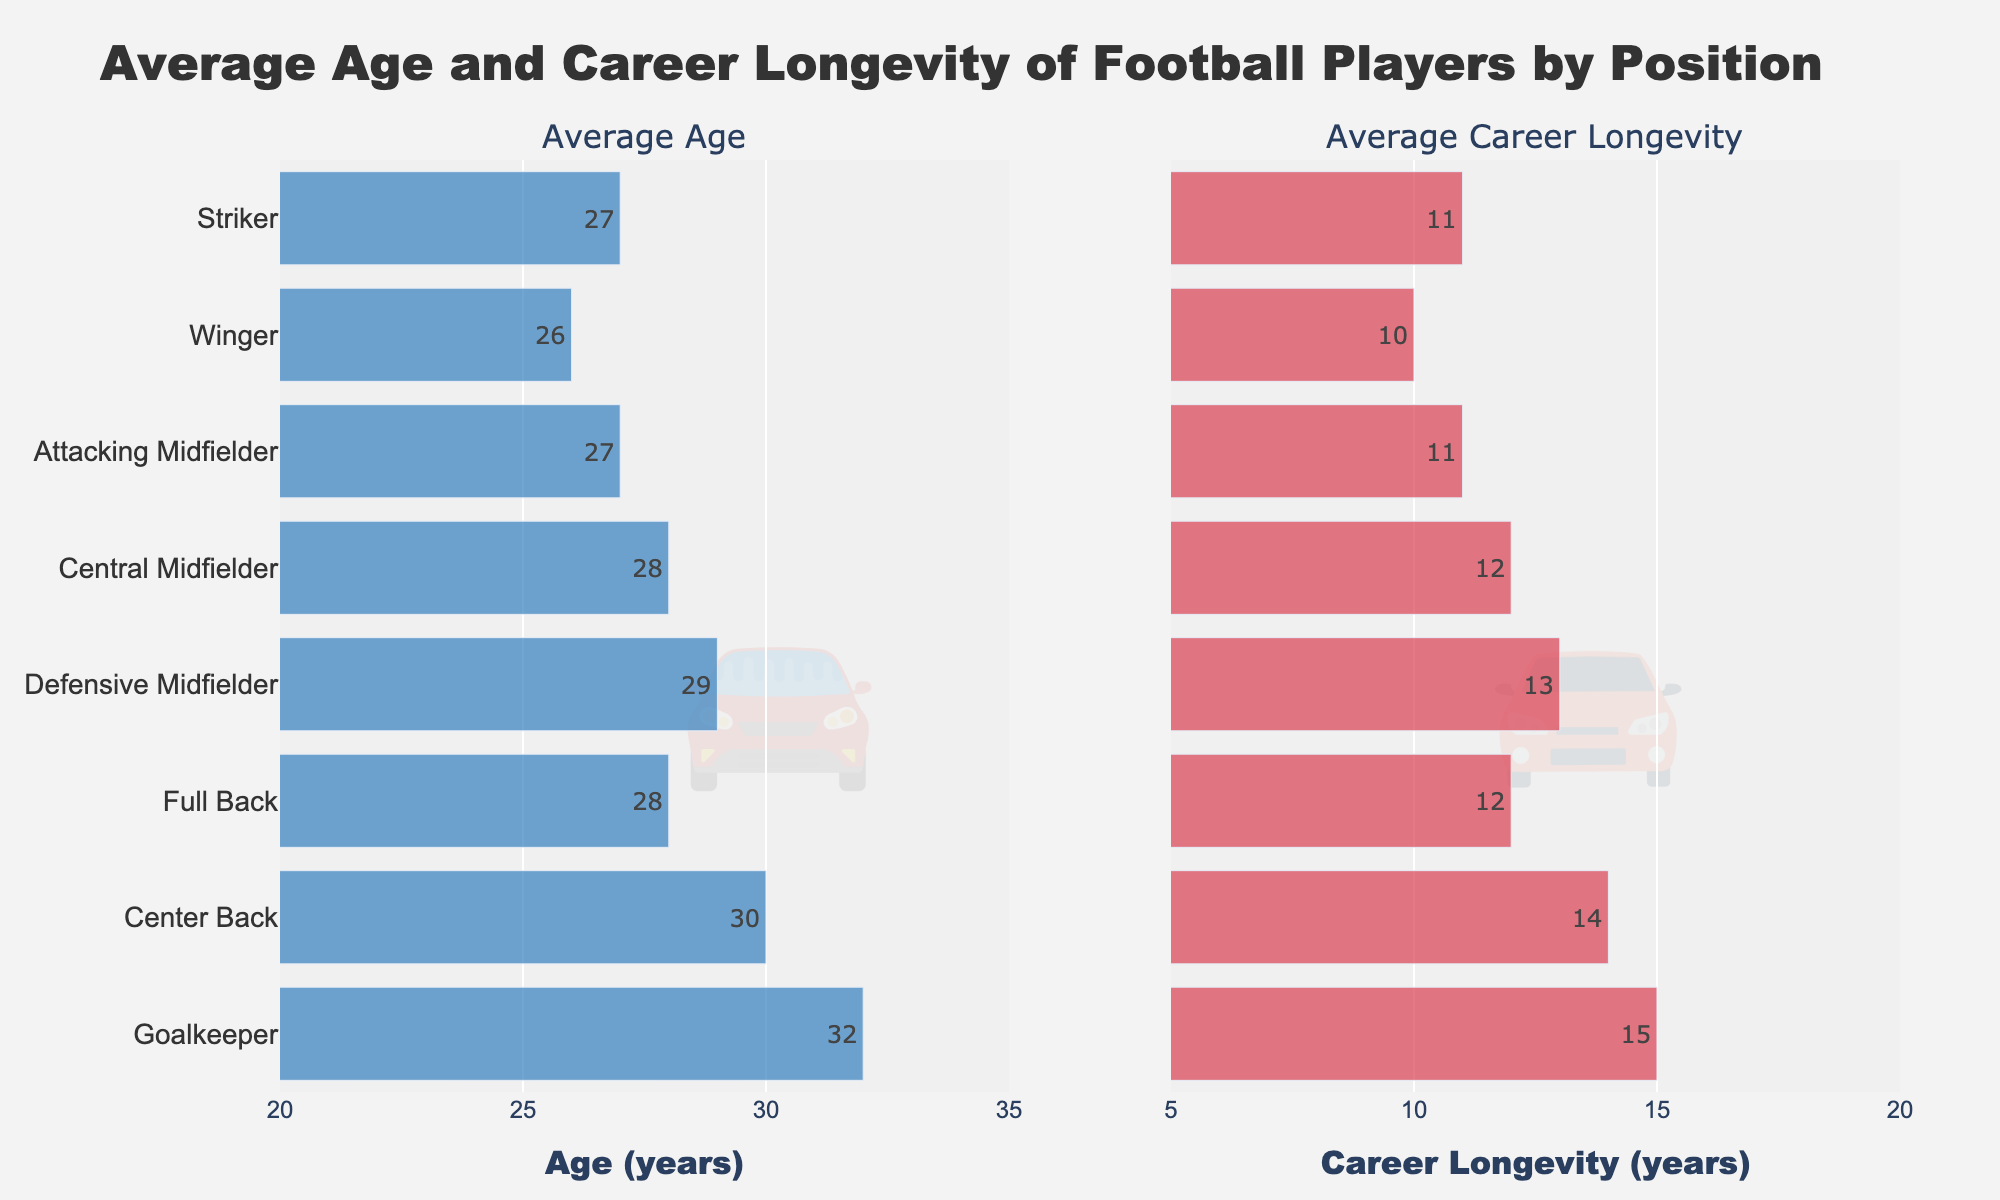What's the position with the highest average age? The figure shows bars representing average ages for each position, and the bar for Goalkeeper is the longest, indicating the highest value.
Answer: Goalkeeper What's the difference in career longevity between a Center Back and a Winger? Center Backs have an average career longevity of 14 years and Wingers have 10 years. Subtract 10 from 14 to get the difference.
Answer: 4 years How much longer, on average, do Goalkeepers play compared to Strikers? Goalkeepers have an average career longevity of 15 years and Strikers have 11 years. Subtract 11 from 15 to find the difference.
Answer: 4 years Which position has the shortest average age, and what is it? The shortest bar in the Average Age column identifies the Winger position with an average age of 26 years.
Answer: Winger, 26 years Compare the average career longevity of Defensive Midfielders and Central Midfielders. Which one is longer and by how much? Defensive Midfielders have an average career longevity of 13 years while Central Midfielders have 12 years. Subtract 12 from 13 to find the difference.
Answer: Defensive Midfielders, 1 year By how many years does the average age of Full Backs exceed that of Wingers? Full Backs have an average age of 28 years and Wingers have 26 years. Subtract 26 from 28 to find the difference.
Answer: 2 years Identify the position with the longest average career longevity and give the value. The longest bar in the Career Longevity column belongs to Goalkeepers with an average of 15 years.
Answer: Goalkeeper, 15 years How many years older are Goalkeepers on average compared to Attacking Midfielders? Goalkeepers have an average age of 32 years and Attacking Midfielders have 27 years. Subtract 27 from 32 to find the difference.
Answer: 5 years What is the average career longevity of positions that have an average age of 28 years? Full Backs and Central Midfielders both have an average age of 28 years. Their respective career longevity values are 12 years each. Calculate the average of these values: (12 + 12) / 2 = 12.
Answer: 12 years 